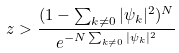<formula> <loc_0><loc_0><loc_500><loc_500>z > \frac { ( 1 - \sum _ { k \neq 0 } | \psi _ { k } | ^ { 2 } ) ^ { N } } { e ^ { - N \sum _ { k \neq 0 } | \psi _ { k } | ^ { 2 } } }</formula> 